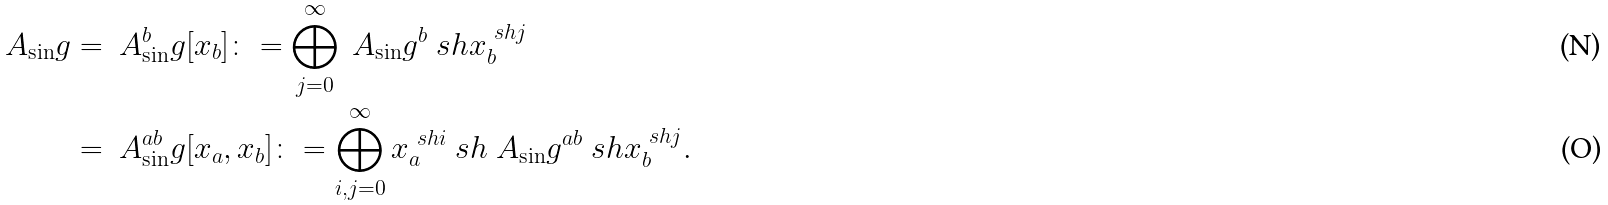<formula> <loc_0><loc_0><loc_500><loc_500>\ A _ { \sin } g & = \ A ^ { b } _ { \sin } g [ x _ { b } ] \colon = \bigoplus _ { j = 0 } ^ { \infty } \ A _ { \sin } g ^ { b } \ s h x _ { b } ^ { \ s h j } \\ & = \ A ^ { a b } _ { \sin } g [ x _ { a } , x _ { b } ] \colon = \bigoplus _ { i , j = 0 } ^ { \infty } x _ { a } ^ { \ s h i } \ s h \ A _ { \sin } g ^ { a b } \ s h x _ { b } ^ { \ s h j } .</formula> 